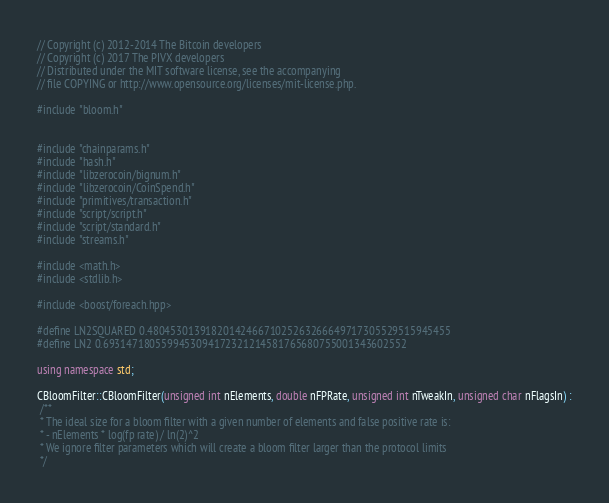<code> <loc_0><loc_0><loc_500><loc_500><_C++_>// Copyright (c) 2012-2014 The Bitcoin developers
// Copyright (c) 2017 The PIVX developers
// Distributed under the MIT software license, see the accompanying
// file COPYING or http://www.opensource.org/licenses/mit-license.php.

#include "bloom.h"


#include "chainparams.h"
#include "hash.h"
#include "libzerocoin/bignum.h"
#include "libzerocoin/CoinSpend.h"
#include "primitives/transaction.h"
#include "script/script.h"
#include "script/standard.h"
#include "streams.h"

#include <math.h>
#include <stdlib.h>

#include <boost/foreach.hpp>

#define LN2SQUARED 0.4804530139182014246671025263266649717305529515945455
#define LN2 0.6931471805599453094172321214581765680755001343602552

using namespace std;

CBloomFilter::CBloomFilter(unsigned int nElements, double nFPRate, unsigned int nTweakIn, unsigned char nFlagsIn) :
 /**	
 * The ideal size for a bloom filter with a given number of elements and false positive rate is:
 * - nElements * log(fp rate) / ln(2)^2
 * We ignore filter parameters which will create a bloom filter larger than the protocol limits
 */</code> 